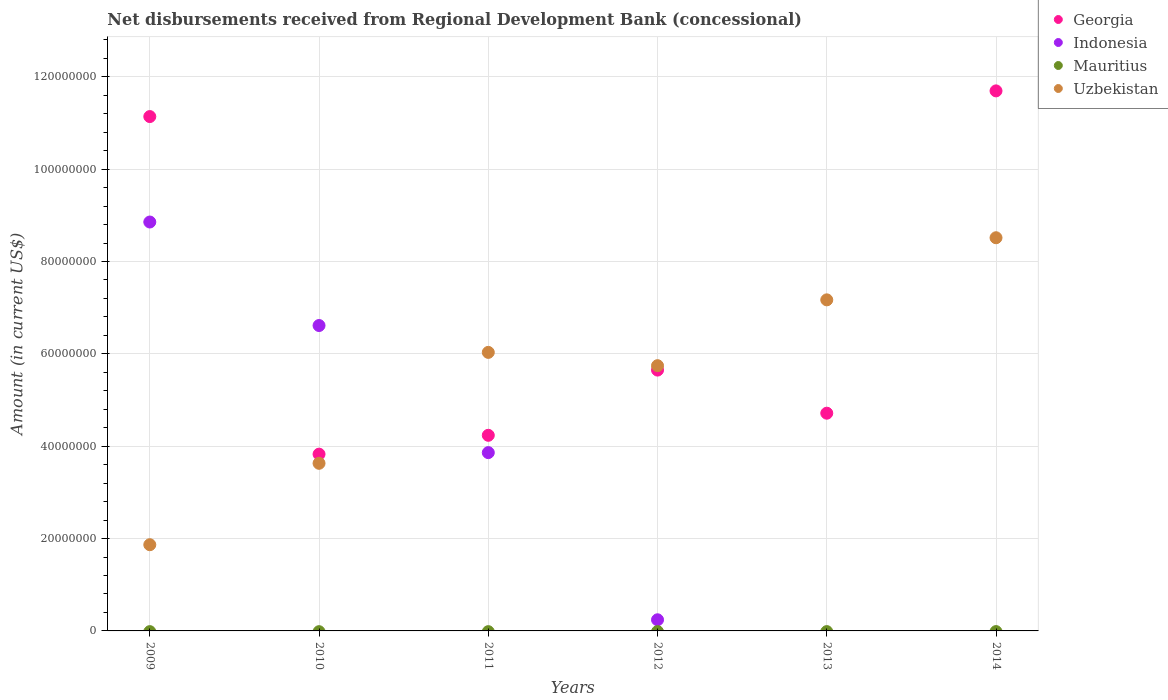What is the amount of disbursements received from Regional Development Bank in Indonesia in 2009?
Ensure brevity in your answer.  8.86e+07. Across all years, what is the maximum amount of disbursements received from Regional Development Bank in Georgia?
Keep it short and to the point. 1.17e+08. In which year was the amount of disbursements received from Regional Development Bank in Georgia maximum?
Your answer should be compact. 2014. What is the total amount of disbursements received from Regional Development Bank in Georgia in the graph?
Keep it short and to the point. 4.13e+08. What is the difference between the amount of disbursements received from Regional Development Bank in Uzbekistan in 2012 and that in 2014?
Give a very brief answer. -2.77e+07. What is the difference between the amount of disbursements received from Regional Development Bank in Uzbekistan in 2014 and the amount of disbursements received from Regional Development Bank in Indonesia in 2009?
Give a very brief answer. -3.41e+06. In the year 2010, what is the difference between the amount of disbursements received from Regional Development Bank in Indonesia and amount of disbursements received from Regional Development Bank in Uzbekistan?
Your answer should be very brief. 2.98e+07. In how many years, is the amount of disbursements received from Regional Development Bank in Uzbekistan greater than 108000000 US$?
Your answer should be compact. 0. What is the ratio of the amount of disbursements received from Regional Development Bank in Georgia in 2012 to that in 2014?
Keep it short and to the point. 0.48. Is the amount of disbursements received from Regional Development Bank in Georgia in 2012 less than that in 2014?
Your answer should be very brief. Yes. What is the difference between the highest and the second highest amount of disbursements received from Regional Development Bank in Indonesia?
Provide a short and direct response. 2.24e+07. What is the difference between the highest and the lowest amount of disbursements received from Regional Development Bank in Indonesia?
Keep it short and to the point. 8.86e+07. In how many years, is the amount of disbursements received from Regional Development Bank in Uzbekistan greater than the average amount of disbursements received from Regional Development Bank in Uzbekistan taken over all years?
Give a very brief answer. 4. Is the sum of the amount of disbursements received from Regional Development Bank in Uzbekistan in 2009 and 2014 greater than the maximum amount of disbursements received from Regional Development Bank in Georgia across all years?
Provide a succinct answer. No. How many years are there in the graph?
Ensure brevity in your answer.  6. What is the difference between two consecutive major ticks on the Y-axis?
Ensure brevity in your answer.  2.00e+07. Where does the legend appear in the graph?
Ensure brevity in your answer.  Top right. What is the title of the graph?
Keep it short and to the point. Net disbursements received from Regional Development Bank (concessional). Does "Brazil" appear as one of the legend labels in the graph?
Offer a very short reply. No. What is the Amount (in current US$) in Georgia in 2009?
Make the answer very short. 1.11e+08. What is the Amount (in current US$) of Indonesia in 2009?
Provide a short and direct response. 8.86e+07. What is the Amount (in current US$) of Uzbekistan in 2009?
Your answer should be very brief. 1.87e+07. What is the Amount (in current US$) in Georgia in 2010?
Offer a very short reply. 3.83e+07. What is the Amount (in current US$) of Indonesia in 2010?
Ensure brevity in your answer.  6.61e+07. What is the Amount (in current US$) of Mauritius in 2010?
Provide a succinct answer. 0. What is the Amount (in current US$) in Uzbekistan in 2010?
Offer a terse response. 3.63e+07. What is the Amount (in current US$) in Georgia in 2011?
Offer a very short reply. 4.24e+07. What is the Amount (in current US$) in Indonesia in 2011?
Ensure brevity in your answer.  3.86e+07. What is the Amount (in current US$) of Uzbekistan in 2011?
Ensure brevity in your answer.  6.03e+07. What is the Amount (in current US$) of Georgia in 2012?
Your response must be concise. 5.65e+07. What is the Amount (in current US$) in Indonesia in 2012?
Provide a short and direct response. 2.41e+06. What is the Amount (in current US$) of Uzbekistan in 2012?
Offer a very short reply. 5.74e+07. What is the Amount (in current US$) in Georgia in 2013?
Ensure brevity in your answer.  4.72e+07. What is the Amount (in current US$) of Mauritius in 2013?
Give a very brief answer. 0. What is the Amount (in current US$) of Uzbekistan in 2013?
Offer a very short reply. 7.17e+07. What is the Amount (in current US$) of Georgia in 2014?
Your response must be concise. 1.17e+08. What is the Amount (in current US$) in Indonesia in 2014?
Provide a succinct answer. 0. What is the Amount (in current US$) in Mauritius in 2014?
Ensure brevity in your answer.  0. What is the Amount (in current US$) in Uzbekistan in 2014?
Your answer should be compact. 8.51e+07. Across all years, what is the maximum Amount (in current US$) of Georgia?
Offer a very short reply. 1.17e+08. Across all years, what is the maximum Amount (in current US$) in Indonesia?
Provide a succinct answer. 8.86e+07. Across all years, what is the maximum Amount (in current US$) of Uzbekistan?
Offer a very short reply. 8.51e+07. Across all years, what is the minimum Amount (in current US$) of Georgia?
Your response must be concise. 3.83e+07. Across all years, what is the minimum Amount (in current US$) of Indonesia?
Make the answer very short. 0. Across all years, what is the minimum Amount (in current US$) in Uzbekistan?
Ensure brevity in your answer.  1.87e+07. What is the total Amount (in current US$) in Georgia in the graph?
Offer a terse response. 4.13e+08. What is the total Amount (in current US$) in Indonesia in the graph?
Give a very brief answer. 1.96e+08. What is the total Amount (in current US$) in Uzbekistan in the graph?
Provide a short and direct response. 3.30e+08. What is the difference between the Amount (in current US$) of Georgia in 2009 and that in 2010?
Keep it short and to the point. 7.31e+07. What is the difference between the Amount (in current US$) of Indonesia in 2009 and that in 2010?
Ensure brevity in your answer.  2.24e+07. What is the difference between the Amount (in current US$) of Uzbekistan in 2009 and that in 2010?
Keep it short and to the point. -1.76e+07. What is the difference between the Amount (in current US$) of Georgia in 2009 and that in 2011?
Your answer should be very brief. 6.90e+07. What is the difference between the Amount (in current US$) in Indonesia in 2009 and that in 2011?
Make the answer very short. 4.99e+07. What is the difference between the Amount (in current US$) in Uzbekistan in 2009 and that in 2011?
Give a very brief answer. -4.16e+07. What is the difference between the Amount (in current US$) in Georgia in 2009 and that in 2012?
Your response must be concise. 5.49e+07. What is the difference between the Amount (in current US$) in Indonesia in 2009 and that in 2012?
Your answer should be very brief. 8.61e+07. What is the difference between the Amount (in current US$) in Uzbekistan in 2009 and that in 2012?
Your answer should be compact. -3.88e+07. What is the difference between the Amount (in current US$) in Georgia in 2009 and that in 2013?
Your answer should be very brief. 6.42e+07. What is the difference between the Amount (in current US$) of Uzbekistan in 2009 and that in 2013?
Provide a short and direct response. -5.30e+07. What is the difference between the Amount (in current US$) of Georgia in 2009 and that in 2014?
Your response must be concise. -5.56e+06. What is the difference between the Amount (in current US$) in Uzbekistan in 2009 and that in 2014?
Offer a terse response. -6.65e+07. What is the difference between the Amount (in current US$) of Georgia in 2010 and that in 2011?
Provide a succinct answer. -4.08e+06. What is the difference between the Amount (in current US$) in Indonesia in 2010 and that in 2011?
Make the answer very short. 2.75e+07. What is the difference between the Amount (in current US$) of Uzbekistan in 2010 and that in 2011?
Your response must be concise. -2.40e+07. What is the difference between the Amount (in current US$) of Georgia in 2010 and that in 2012?
Ensure brevity in your answer.  -1.82e+07. What is the difference between the Amount (in current US$) of Indonesia in 2010 and that in 2012?
Keep it short and to the point. 6.37e+07. What is the difference between the Amount (in current US$) in Uzbekistan in 2010 and that in 2012?
Your response must be concise. -2.11e+07. What is the difference between the Amount (in current US$) of Georgia in 2010 and that in 2013?
Your answer should be compact. -8.87e+06. What is the difference between the Amount (in current US$) of Uzbekistan in 2010 and that in 2013?
Give a very brief answer. -3.54e+07. What is the difference between the Amount (in current US$) in Georgia in 2010 and that in 2014?
Your answer should be very brief. -7.87e+07. What is the difference between the Amount (in current US$) of Uzbekistan in 2010 and that in 2014?
Your answer should be compact. -4.88e+07. What is the difference between the Amount (in current US$) in Georgia in 2011 and that in 2012?
Offer a terse response. -1.41e+07. What is the difference between the Amount (in current US$) in Indonesia in 2011 and that in 2012?
Offer a terse response. 3.62e+07. What is the difference between the Amount (in current US$) in Uzbekistan in 2011 and that in 2012?
Your response must be concise. 2.88e+06. What is the difference between the Amount (in current US$) in Georgia in 2011 and that in 2013?
Keep it short and to the point. -4.79e+06. What is the difference between the Amount (in current US$) of Uzbekistan in 2011 and that in 2013?
Offer a terse response. -1.14e+07. What is the difference between the Amount (in current US$) in Georgia in 2011 and that in 2014?
Give a very brief answer. -7.46e+07. What is the difference between the Amount (in current US$) of Uzbekistan in 2011 and that in 2014?
Your answer should be compact. -2.48e+07. What is the difference between the Amount (in current US$) of Georgia in 2012 and that in 2013?
Your response must be concise. 9.34e+06. What is the difference between the Amount (in current US$) of Uzbekistan in 2012 and that in 2013?
Keep it short and to the point. -1.43e+07. What is the difference between the Amount (in current US$) in Georgia in 2012 and that in 2014?
Your answer should be very brief. -6.05e+07. What is the difference between the Amount (in current US$) of Uzbekistan in 2012 and that in 2014?
Your response must be concise. -2.77e+07. What is the difference between the Amount (in current US$) of Georgia in 2013 and that in 2014?
Offer a terse response. -6.98e+07. What is the difference between the Amount (in current US$) in Uzbekistan in 2013 and that in 2014?
Offer a terse response. -1.34e+07. What is the difference between the Amount (in current US$) of Georgia in 2009 and the Amount (in current US$) of Indonesia in 2010?
Provide a succinct answer. 4.53e+07. What is the difference between the Amount (in current US$) of Georgia in 2009 and the Amount (in current US$) of Uzbekistan in 2010?
Keep it short and to the point. 7.51e+07. What is the difference between the Amount (in current US$) in Indonesia in 2009 and the Amount (in current US$) in Uzbekistan in 2010?
Ensure brevity in your answer.  5.23e+07. What is the difference between the Amount (in current US$) in Georgia in 2009 and the Amount (in current US$) in Indonesia in 2011?
Offer a terse response. 7.28e+07. What is the difference between the Amount (in current US$) of Georgia in 2009 and the Amount (in current US$) of Uzbekistan in 2011?
Provide a short and direct response. 5.11e+07. What is the difference between the Amount (in current US$) in Indonesia in 2009 and the Amount (in current US$) in Uzbekistan in 2011?
Keep it short and to the point. 2.82e+07. What is the difference between the Amount (in current US$) in Georgia in 2009 and the Amount (in current US$) in Indonesia in 2012?
Give a very brief answer. 1.09e+08. What is the difference between the Amount (in current US$) in Georgia in 2009 and the Amount (in current US$) in Uzbekistan in 2012?
Your response must be concise. 5.39e+07. What is the difference between the Amount (in current US$) in Indonesia in 2009 and the Amount (in current US$) in Uzbekistan in 2012?
Your answer should be very brief. 3.11e+07. What is the difference between the Amount (in current US$) of Georgia in 2009 and the Amount (in current US$) of Uzbekistan in 2013?
Ensure brevity in your answer.  3.97e+07. What is the difference between the Amount (in current US$) in Indonesia in 2009 and the Amount (in current US$) in Uzbekistan in 2013?
Your answer should be compact. 1.69e+07. What is the difference between the Amount (in current US$) of Georgia in 2009 and the Amount (in current US$) of Uzbekistan in 2014?
Offer a very short reply. 2.62e+07. What is the difference between the Amount (in current US$) in Indonesia in 2009 and the Amount (in current US$) in Uzbekistan in 2014?
Give a very brief answer. 3.41e+06. What is the difference between the Amount (in current US$) in Georgia in 2010 and the Amount (in current US$) in Indonesia in 2011?
Your answer should be compact. -3.31e+05. What is the difference between the Amount (in current US$) in Georgia in 2010 and the Amount (in current US$) in Uzbekistan in 2011?
Keep it short and to the point. -2.20e+07. What is the difference between the Amount (in current US$) of Indonesia in 2010 and the Amount (in current US$) of Uzbekistan in 2011?
Provide a succinct answer. 5.82e+06. What is the difference between the Amount (in current US$) of Georgia in 2010 and the Amount (in current US$) of Indonesia in 2012?
Ensure brevity in your answer.  3.59e+07. What is the difference between the Amount (in current US$) in Georgia in 2010 and the Amount (in current US$) in Uzbekistan in 2012?
Provide a succinct answer. -1.92e+07. What is the difference between the Amount (in current US$) of Indonesia in 2010 and the Amount (in current US$) of Uzbekistan in 2012?
Give a very brief answer. 8.70e+06. What is the difference between the Amount (in current US$) in Georgia in 2010 and the Amount (in current US$) in Uzbekistan in 2013?
Offer a terse response. -3.34e+07. What is the difference between the Amount (in current US$) in Indonesia in 2010 and the Amount (in current US$) in Uzbekistan in 2013?
Offer a very short reply. -5.56e+06. What is the difference between the Amount (in current US$) in Georgia in 2010 and the Amount (in current US$) in Uzbekistan in 2014?
Give a very brief answer. -4.69e+07. What is the difference between the Amount (in current US$) of Indonesia in 2010 and the Amount (in current US$) of Uzbekistan in 2014?
Provide a succinct answer. -1.90e+07. What is the difference between the Amount (in current US$) in Georgia in 2011 and the Amount (in current US$) in Indonesia in 2012?
Offer a terse response. 3.99e+07. What is the difference between the Amount (in current US$) in Georgia in 2011 and the Amount (in current US$) in Uzbekistan in 2012?
Give a very brief answer. -1.51e+07. What is the difference between the Amount (in current US$) in Indonesia in 2011 and the Amount (in current US$) in Uzbekistan in 2012?
Make the answer very short. -1.88e+07. What is the difference between the Amount (in current US$) of Georgia in 2011 and the Amount (in current US$) of Uzbekistan in 2013?
Offer a very short reply. -2.93e+07. What is the difference between the Amount (in current US$) in Indonesia in 2011 and the Amount (in current US$) in Uzbekistan in 2013?
Keep it short and to the point. -3.31e+07. What is the difference between the Amount (in current US$) in Georgia in 2011 and the Amount (in current US$) in Uzbekistan in 2014?
Make the answer very short. -4.28e+07. What is the difference between the Amount (in current US$) of Indonesia in 2011 and the Amount (in current US$) of Uzbekistan in 2014?
Your answer should be compact. -4.65e+07. What is the difference between the Amount (in current US$) in Georgia in 2012 and the Amount (in current US$) in Uzbekistan in 2013?
Provide a short and direct response. -1.52e+07. What is the difference between the Amount (in current US$) in Indonesia in 2012 and the Amount (in current US$) in Uzbekistan in 2013?
Your response must be concise. -6.93e+07. What is the difference between the Amount (in current US$) in Georgia in 2012 and the Amount (in current US$) in Uzbekistan in 2014?
Give a very brief answer. -2.87e+07. What is the difference between the Amount (in current US$) in Indonesia in 2012 and the Amount (in current US$) in Uzbekistan in 2014?
Keep it short and to the point. -8.27e+07. What is the difference between the Amount (in current US$) of Georgia in 2013 and the Amount (in current US$) of Uzbekistan in 2014?
Your answer should be compact. -3.80e+07. What is the average Amount (in current US$) of Georgia per year?
Provide a succinct answer. 6.88e+07. What is the average Amount (in current US$) of Indonesia per year?
Your response must be concise. 3.26e+07. What is the average Amount (in current US$) of Uzbekistan per year?
Offer a terse response. 5.49e+07. In the year 2009, what is the difference between the Amount (in current US$) of Georgia and Amount (in current US$) of Indonesia?
Your answer should be compact. 2.28e+07. In the year 2009, what is the difference between the Amount (in current US$) in Georgia and Amount (in current US$) in Uzbekistan?
Keep it short and to the point. 9.27e+07. In the year 2009, what is the difference between the Amount (in current US$) in Indonesia and Amount (in current US$) in Uzbekistan?
Provide a succinct answer. 6.99e+07. In the year 2010, what is the difference between the Amount (in current US$) in Georgia and Amount (in current US$) in Indonesia?
Your response must be concise. -2.79e+07. In the year 2010, what is the difference between the Amount (in current US$) in Georgia and Amount (in current US$) in Uzbekistan?
Give a very brief answer. 1.98e+06. In the year 2010, what is the difference between the Amount (in current US$) in Indonesia and Amount (in current US$) in Uzbekistan?
Provide a succinct answer. 2.98e+07. In the year 2011, what is the difference between the Amount (in current US$) of Georgia and Amount (in current US$) of Indonesia?
Your response must be concise. 3.75e+06. In the year 2011, what is the difference between the Amount (in current US$) of Georgia and Amount (in current US$) of Uzbekistan?
Provide a short and direct response. -1.80e+07. In the year 2011, what is the difference between the Amount (in current US$) in Indonesia and Amount (in current US$) in Uzbekistan?
Offer a very short reply. -2.17e+07. In the year 2012, what is the difference between the Amount (in current US$) in Georgia and Amount (in current US$) in Indonesia?
Offer a terse response. 5.41e+07. In the year 2012, what is the difference between the Amount (in current US$) of Georgia and Amount (in current US$) of Uzbekistan?
Give a very brief answer. -9.56e+05. In the year 2012, what is the difference between the Amount (in current US$) in Indonesia and Amount (in current US$) in Uzbekistan?
Make the answer very short. -5.50e+07. In the year 2013, what is the difference between the Amount (in current US$) of Georgia and Amount (in current US$) of Uzbekistan?
Your response must be concise. -2.45e+07. In the year 2014, what is the difference between the Amount (in current US$) in Georgia and Amount (in current US$) in Uzbekistan?
Provide a succinct answer. 3.18e+07. What is the ratio of the Amount (in current US$) of Georgia in 2009 to that in 2010?
Keep it short and to the point. 2.91. What is the ratio of the Amount (in current US$) in Indonesia in 2009 to that in 2010?
Make the answer very short. 1.34. What is the ratio of the Amount (in current US$) of Uzbekistan in 2009 to that in 2010?
Provide a succinct answer. 0.51. What is the ratio of the Amount (in current US$) of Georgia in 2009 to that in 2011?
Provide a succinct answer. 2.63. What is the ratio of the Amount (in current US$) in Indonesia in 2009 to that in 2011?
Offer a very short reply. 2.29. What is the ratio of the Amount (in current US$) of Uzbekistan in 2009 to that in 2011?
Offer a very short reply. 0.31. What is the ratio of the Amount (in current US$) in Georgia in 2009 to that in 2012?
Provide a succinct answer. 1.97. What is the ratio of the Amount (in current US$) of Indonesia in 2009 to that in 2012?
Make the answer very short. 36.7. What is the ratio of the Amount (in current US$) in Uzbekistan in 2009 to that in 2012?
Offer a terse response. 0.33. What is the ratio of the Amount (in current US$) of Georgia in 2009 to that in 2013?
Make the answer very short. 2.36. What is the ratio of the Amount (in current US$) of Uzbekistan in 2009 to that in 2013?
Your answer should be compact. 0.26. What is the ratio of the Amount (in current US$) in Georgia in 2009 to that in 2014?
Your answer should be very brief. 0.95. What is the ratio of the Amount (in current US$) of Uzbekistan in 2009 to that in 2014?
Ensure brevity in your answer.  0.22. What is the ratio of the Amount (in current US$) of Georgia in 2010 to that in 2011?
Make the answer very short. 0.9. What is the ratio of the Amount (in current US$) in Indonesia in 2010 to that in 2011?
Offer a very short reply. 1.71. What is the ratio of the Amount (in current US$) of Uzbekistan in 2010 to that in 2011?
Provide a short and direct response. 0.6. What is the ratio of the Amount (in current US$) in Georgia in 2010 to that in 2012?
Offer a very short reply. 0.68. What is the ratio of the Amount (in current US$) of Indonesia in 2010 to that in 2012?
Offer a very short reply. 27.41. What is the ratio of the Amount (in current US$) of Uzbekistan in 2010 to that in 2012?
Your response must be concise. 0.63. What is the ratio of the Amount (in current US$) in Georgia in 2010 to that in 2013?
Ensure brevity in your answer.  0.81. What is the ratio of the Amount (in current US$) in Uzbekistan in 2010 to that in 2013?
Provide a short and direct response. 0.51. What is the ratio of the Amount (in current US$) of Georgia in 2010 to that in 2014?
Ensure brevity in your answer.  0.33. What is the ratio of the Amount (in current US$) of Uzbekistan in 2010 to that in 2014?
Your response must be concise. 0.43. What is the ratio of the Amount (in current US$) of Indonesia in 2011 to that in 2012?
Offer a very short reply. 16. What is the ratio of the Amount (in current US$) in Uzbekistan in 2011 to that in 2012?
Offer a very short reply. 1.05. What is the ratio of the Amount (in current US$) in Georgia in 2011 to that in 2013?
Your answer should be very brief. 0.9. What is the ratio of the Amount (in current US$) in Uzbekistan in 2011 to that in 2013?
Ensure brevity in your answer.  0.84. What is the ratio of the Amount (in current US$) of Georgia in 2011 to that in 2014?
Your answer should be compact. 0.36. What is the ratio of the Amount (in current US$) of Uzbekistan in 2011 to that in 2014?
Your answer should be very brief. 0.71. What is the ratio of the Amount (in current US$) of Georgia in 2012 to that in 2013?
Your answer should be very brief. 1.2. What is the ratio of the Amount (in current US$) of Uzbekistan in 2012 to that in 2013?
Make the answer very short. 0.8. What is the ratio of the Amount (in current US$) in Georgia in 2012 to that in 2014?
Your response must be concise. 0.48. What is the ratio of the Amount (in current US$) of Uzbekistan in 2012 to that in 2014?
Your response must be concise. 0.67. What is the ratio of the Amount (in current US$) of Georgia in 2013 to that in 2014?
Your answer should be compact. 0.4. What is the ratio of the Amount (in current US$) in Uzbekistan in 2013 to that in 2014?
Offer a terse response. 0.84. What is the difference between the highest and the second highest Amount (in current US$) in Georgia?
Your answer should be very brief. 5.56e+06. What is the difference between the highest and the second highest Amount (in current US$) of Indonesia?
Make the answer very short. 2.24e+07. What is the difference between the highest and the second highest Amount (in current US$) of Uzbekistan?
Offer a terse response. 1.34e+07. What is the difference between the highest and the lowest Amount (in current US$) of Georgia?
Offer a terse response. 7.87e+07. What is the difference between the highest and the lowest Amount (in current US$) of Indonesia?
Keep it short and to the point. 8.86e+07. What is the difference between the highest and the lowest Amount (in current US$) of Uzbekistan?
Give a very brief answer. 6.65e+07. 